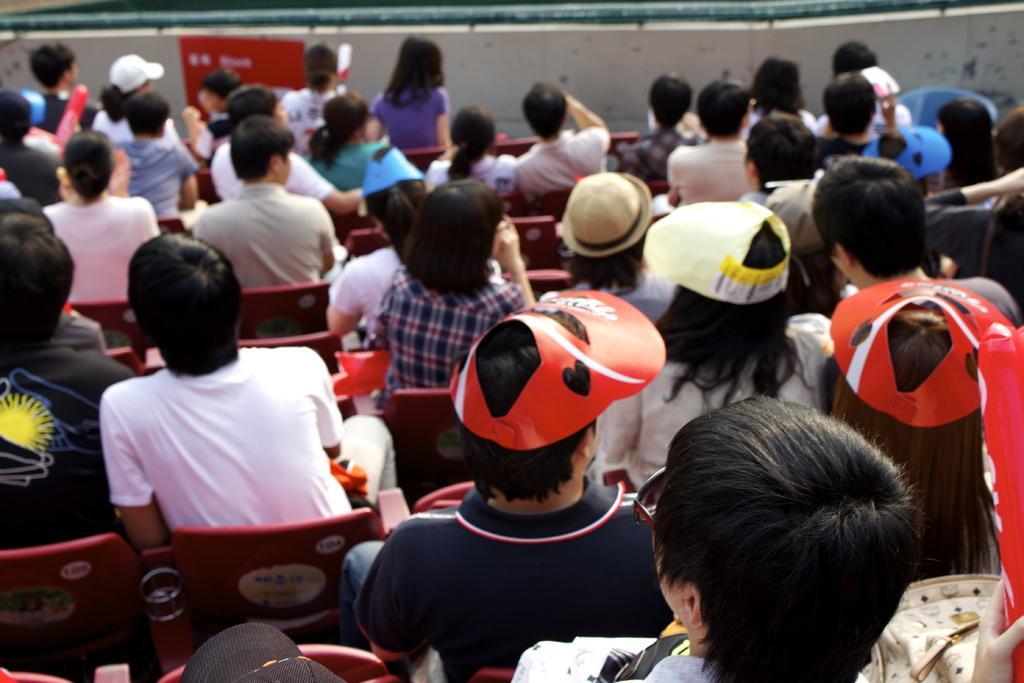In one or two sentences, can you explain what this image depicts? In the picture we can see a number of people sitting on the chairs and some people are wearing a cap and hat and in the background, we can see a wall with some railing pipe to it and to the wall we can see a red color poster. 